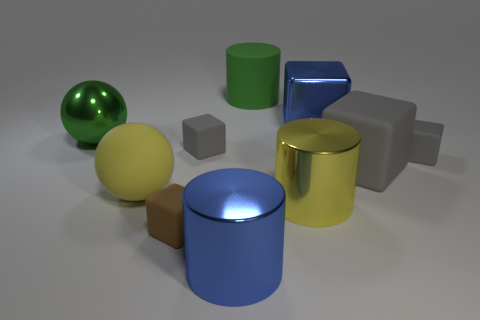How many gray cubes must be subtracted to get 1 gray cubes? 2 Subtract all red spheres. How many gray cubes are left? 3 Subtract all small brown blocks. How many blocks are left? 4 Subtract all brown cubes. How many cubes are left? 4 Subtract all purple cubes. Subtract all blue spheres. How many cubes are left? 5 Subtract all balls. How many objects are left? 8 Subtract 1 brown blocks. How many objects are left? 9 Subtract all brown shiny balls. Subtract all large gray matte objects. How many objects are left? 9 Add 3 big blue metal cylinders. How many big blue metal cylinders are left? 4 Add 2 large rubber cubes. How many large rubber cubes exist? 3 